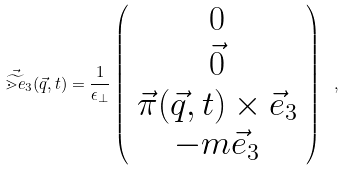Convert formula to latex. <formula><loc_0><loc_0><loc_500><loc_500>\vec { \widetilde { \mathbb { m } { e } } } _ { 3 } ( \vec { q } , t ) = \frac { 1 } { \epsilon _ { \perp } } \left ( \begin{array} { c } 0 \\ \vec { 0 } \\ \vec { \pi } ( \vec { q } , t ) \times \vec { e } _ { 3 } \\ - m \vec { e } _ { 3 } \end{array} \right ) \ ,</formula> 